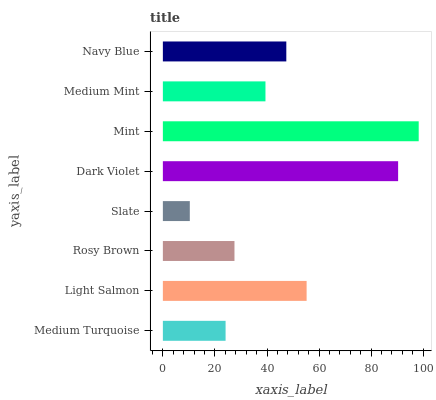Is Slate the minimum?
Answer yes or no. Yes. Is Mint the maximum?
Answer yes or no. Yes. Is Light Salmon the minimum?
Answer yes or no. No. Is Light Salmon the maximum?
Answer yes or no. No. Is Light Salmon greater than Medium Turquoise?
Answer yes or no. Yes. Is Medium Turquoise less than Light Salmon?
Answer yes or no. Yes. Is Medium Turquoise greater than Light Salmon?
Answer yes or no. No. Is Light Salmon less than Medium Turquoise?
Answer yes or no. No. Is Navy Blue the high median?
Answer yes or no. Yes. Is Medium Mint the low median?
Answer yes or no. Yes. Is Rosy Brown the high median?
Answer yes or no. No. Is Medium Turquoise the low median?
Answer yes or no. No. 